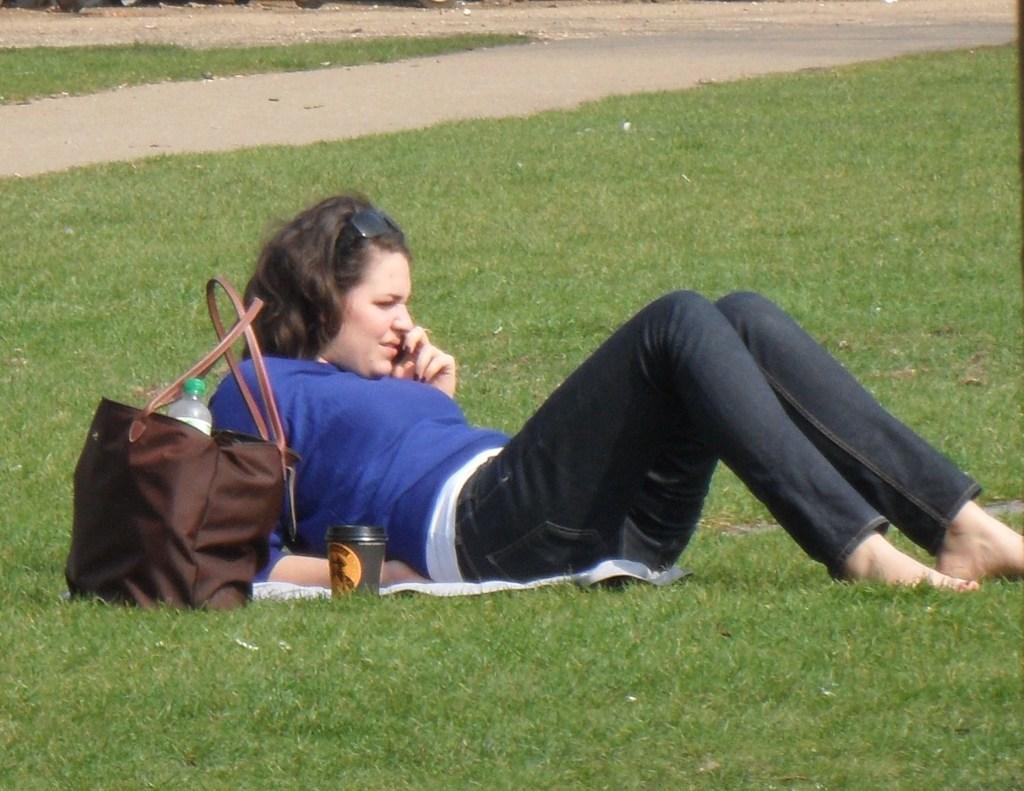Describe this image in one or two sentences. In this image, I can see a girl sitting on the grass, and I can see a bag ,bottle and a cup. 